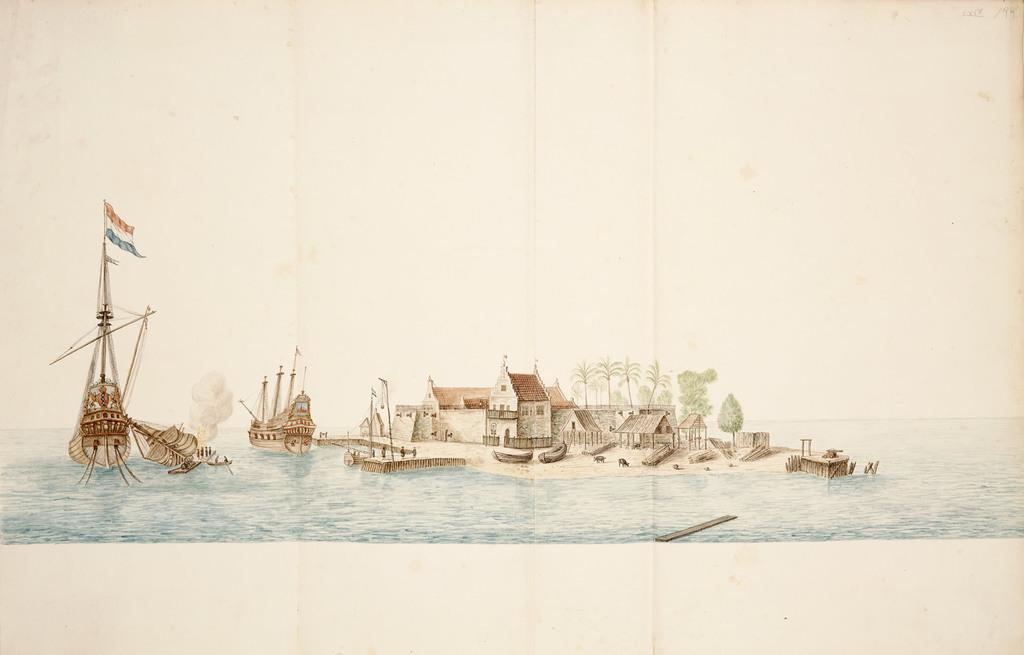What is depicted on the poster in the image? The poster contains ships, boats, houses, a shed, poles, a flag, and water. Can you describe the setting of the poster? The poster depicts a coastal or harbor setting, with various types of vessels and structures. What type of horn can be heard in the image? There is no horn present in the image, as it is a static poster. 